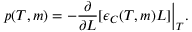<formula> <loc_0><loc_0><loc_500><loc_500>p ( T , m ) = - \frac { \partial } { \partial L } [ \epsilon _ { C } ( T , m ) L ] \Big | _ { T } .</formula> 